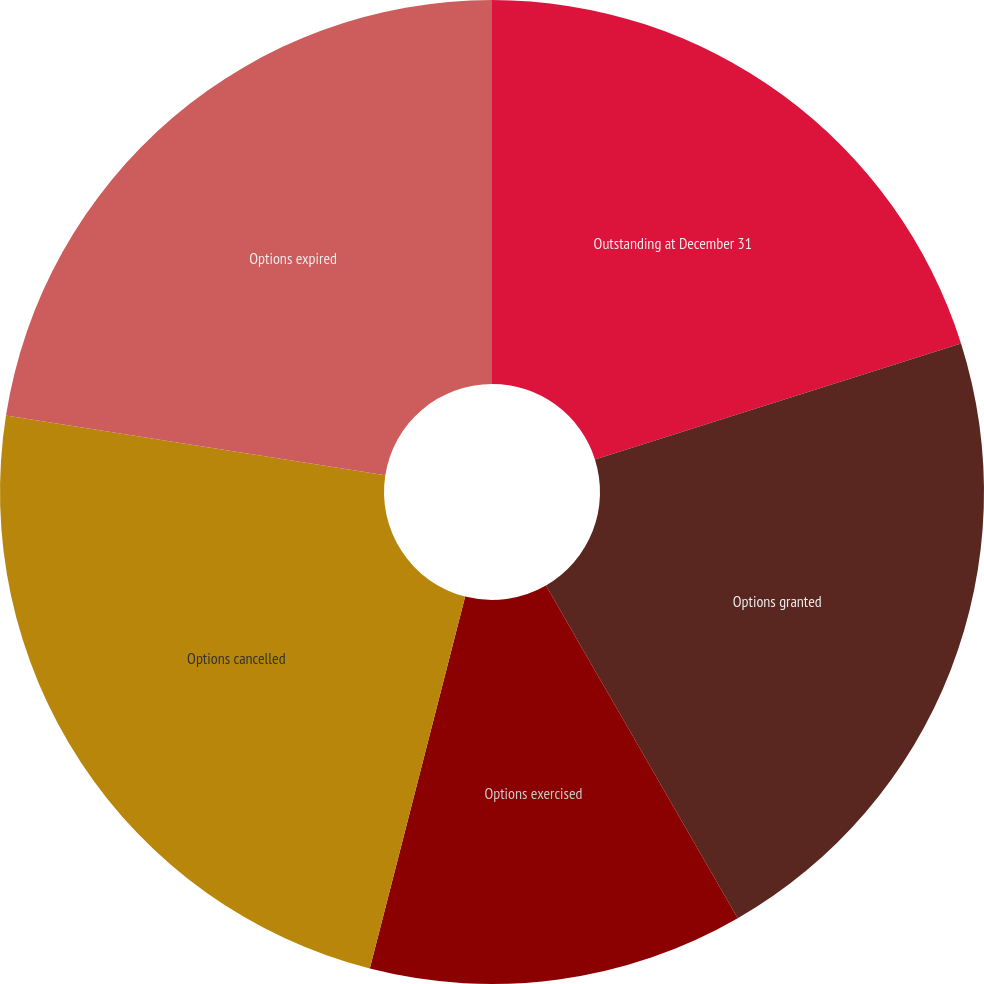Convert chart to OTSL. <chart><loc_0><loc_0><loc_500><loc_500><pie_chart><fcel>Outstanding at December 31<fcel>Options granted<fcel>Options exercised<fcel>Options cancelled<fcel>Options expired<nl><fcel>20.12%<fcel>21.56%<fcel>12.32%<fcel>23.49%<fcel>22.52%<nl></chart> 